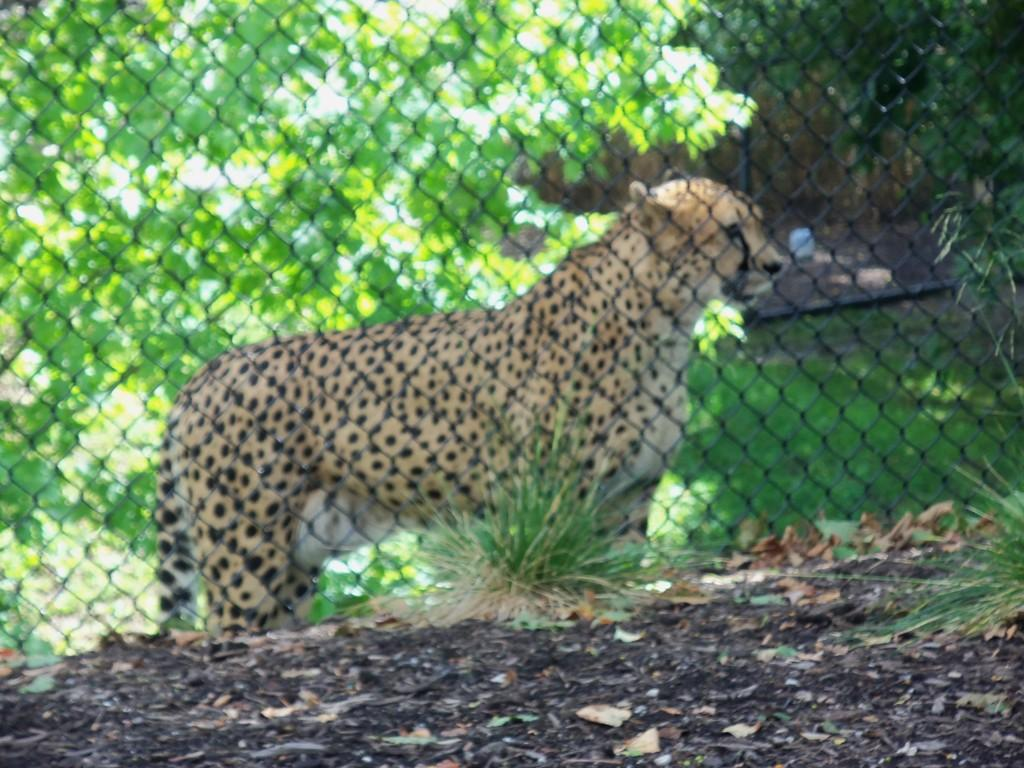What type of vegetation is present at the bottom of the image? There is grass and leaves on the ground at the bottom of the image. What animal can be seen in the background of the image? There is a cheetah at the fence in the background of the image. What else can be seen in the background of the image? There are trees and grass in the background of the image. How many cacti are visible in the image? There are no cacti present in the image. What time of day is it in the image, based on the presence of spiders? There is no mention of spiders in the image, and therefore we cannot determine the time of day based on their presence. 